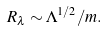<formula> <loc_0><loc_0><loc_500><loc_500>R _ { \lambda } \sim \Lambda ^ { 1 / 2 } / m .</formula> 